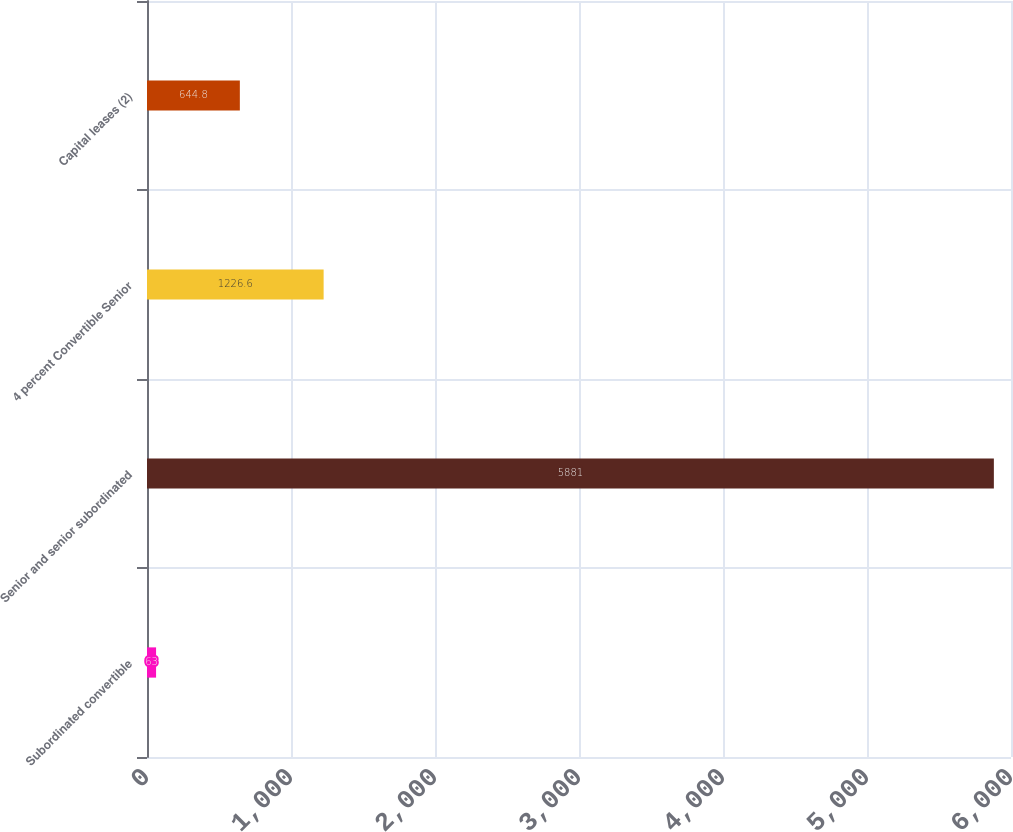<chart> <loc_0><loc_0><loc_500><loc_500><bar_chart><fcel>Subordinated convertible<fcel>Senior and senior subordinated<fcel>4 percent Convertible Senior<fcel>Capital leases (2)<nl><fcel>63<fcel>5881<fcel>1226.6<fcel>644.8<nl></chart> 